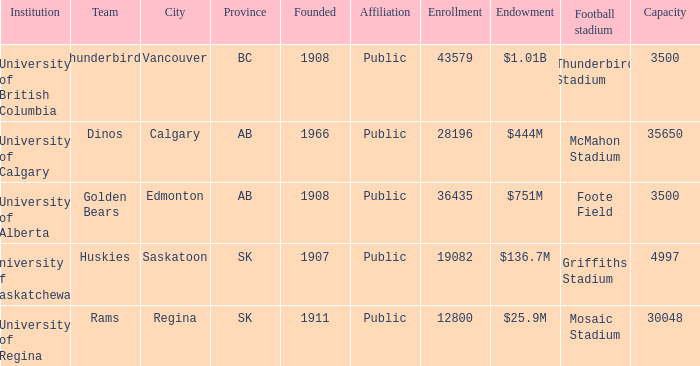What is the capacity for the organization of university of alberta? 3500.0. 